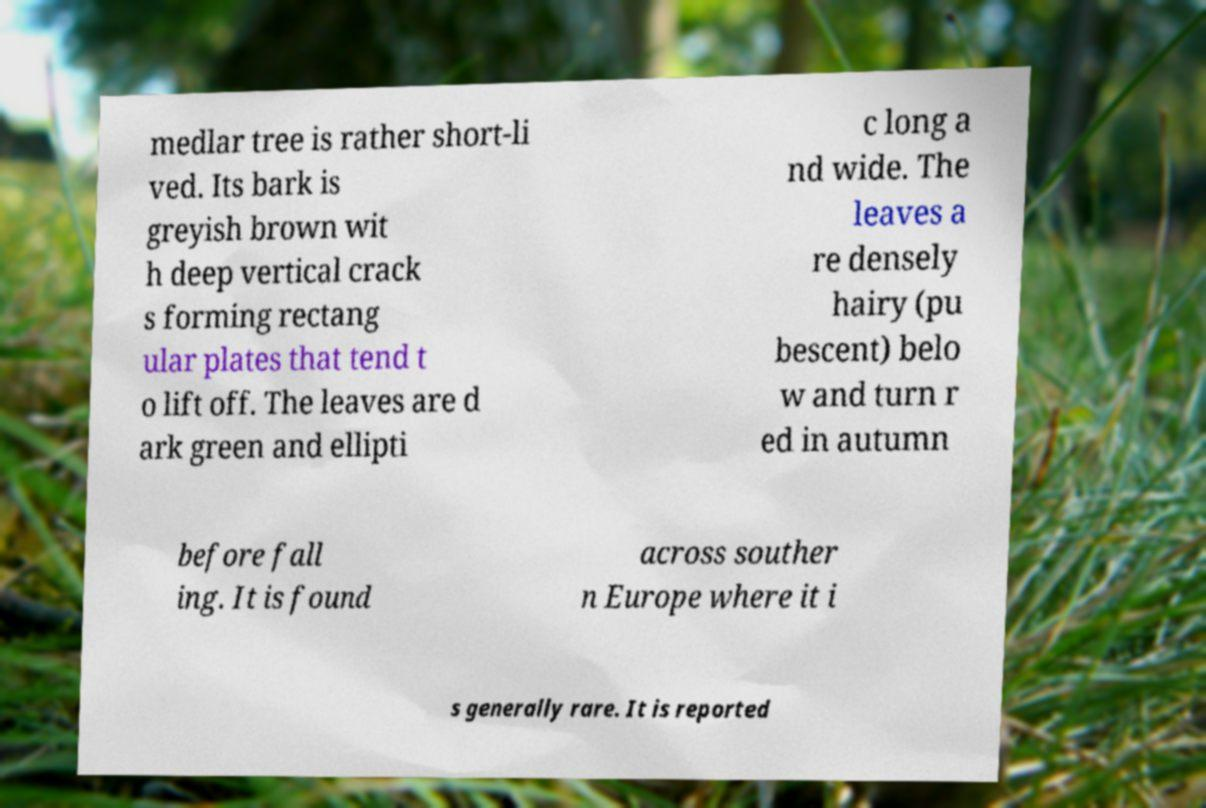I need the written content from this picture converted into text. Can you do that? medlar tree is rather short-li ved. Its bark is greyish brown wit h deep vertical crack s forming rectang ular plates that tend t o lift off. The leaves are d ark green and ellipti c long a nd wide. The leaves a re densely hairy (pu bescent) belo w and turn r ed in autumn before fall ing. It is found across souther n Europe where it i s generally rare. It is reported 